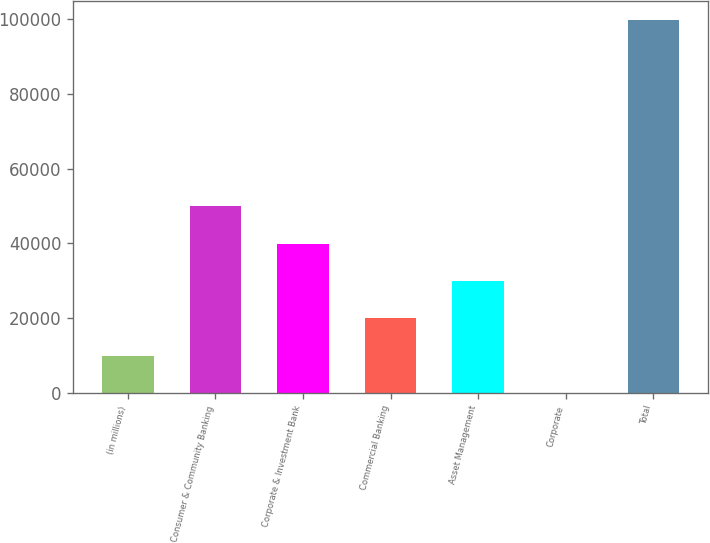Convert chart to OTSL. <chart><loc_0><loc_0><loc_500><loc_500><bar_chart><fcel>(in millions)<fcel>Consumer & Community Banking<fcel>Corporate & Investment Bank<fcel>Commercial Banking<fcel>Asset Management<fcel>Corporate<fcel>Total<nl><fcel>9999.6<fcel>49910<fcel>39932.4<fcel>19977.2<fcel>29954.8<fcel>22<fcel>99798<nl></chart> 